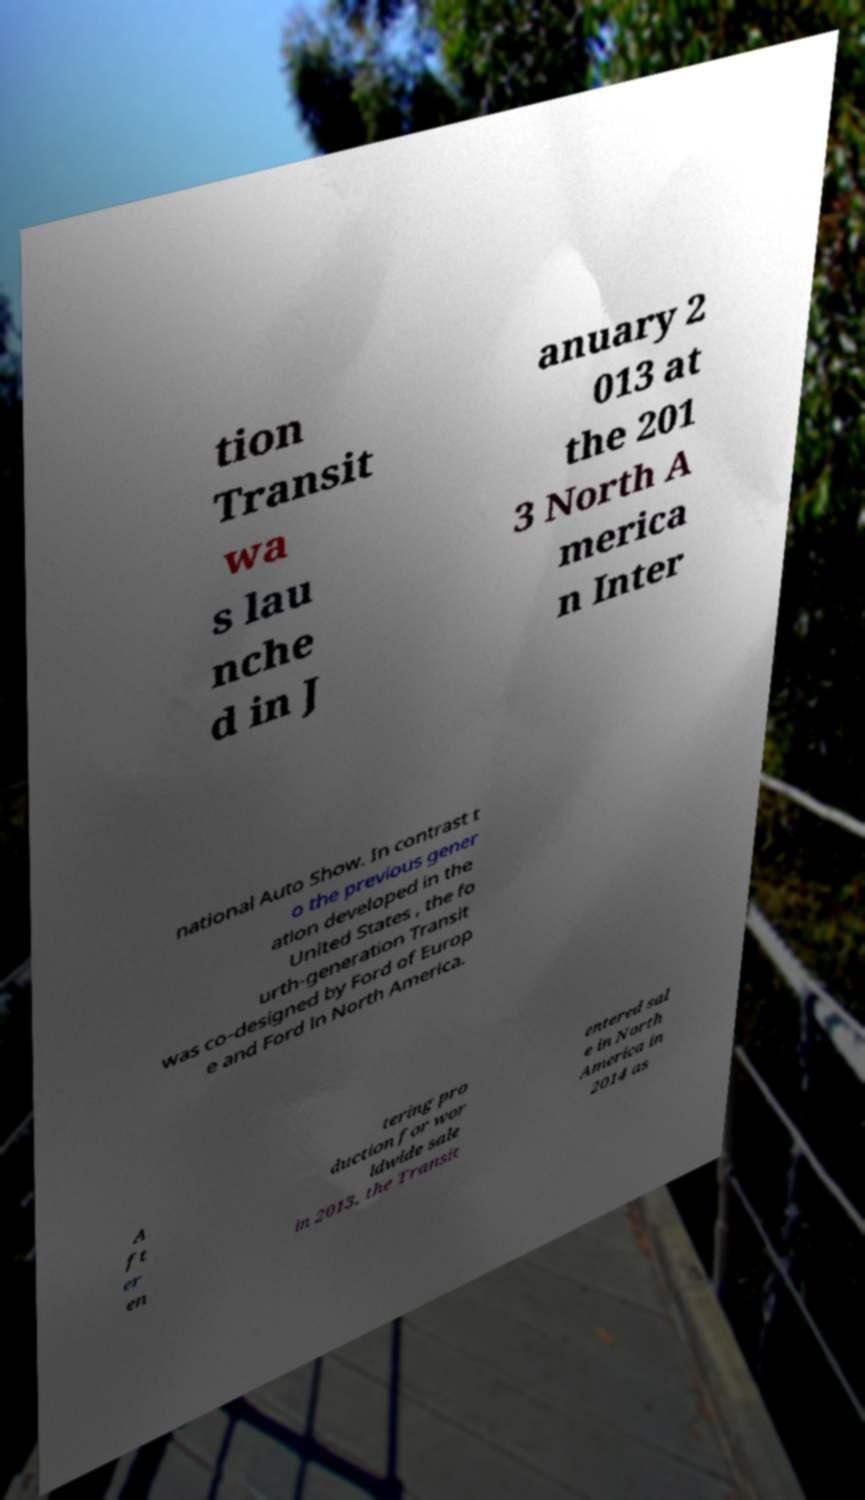Could you assist in decoding the text presented in this image and type it out clearly? tion Transit wa s lau nche d in J anuary 2 013 at the 201 3 North A merica n Inter national Auto Show. In contrast t o the previous gener ation developed in the United States , the fo urth-generation Transit was co-designed by Ford of Europ e and Ford in North America. A ft er en tering pro duction for wor ldwide sale in 2013, the Transit entered sal e in North America in 2014 as 